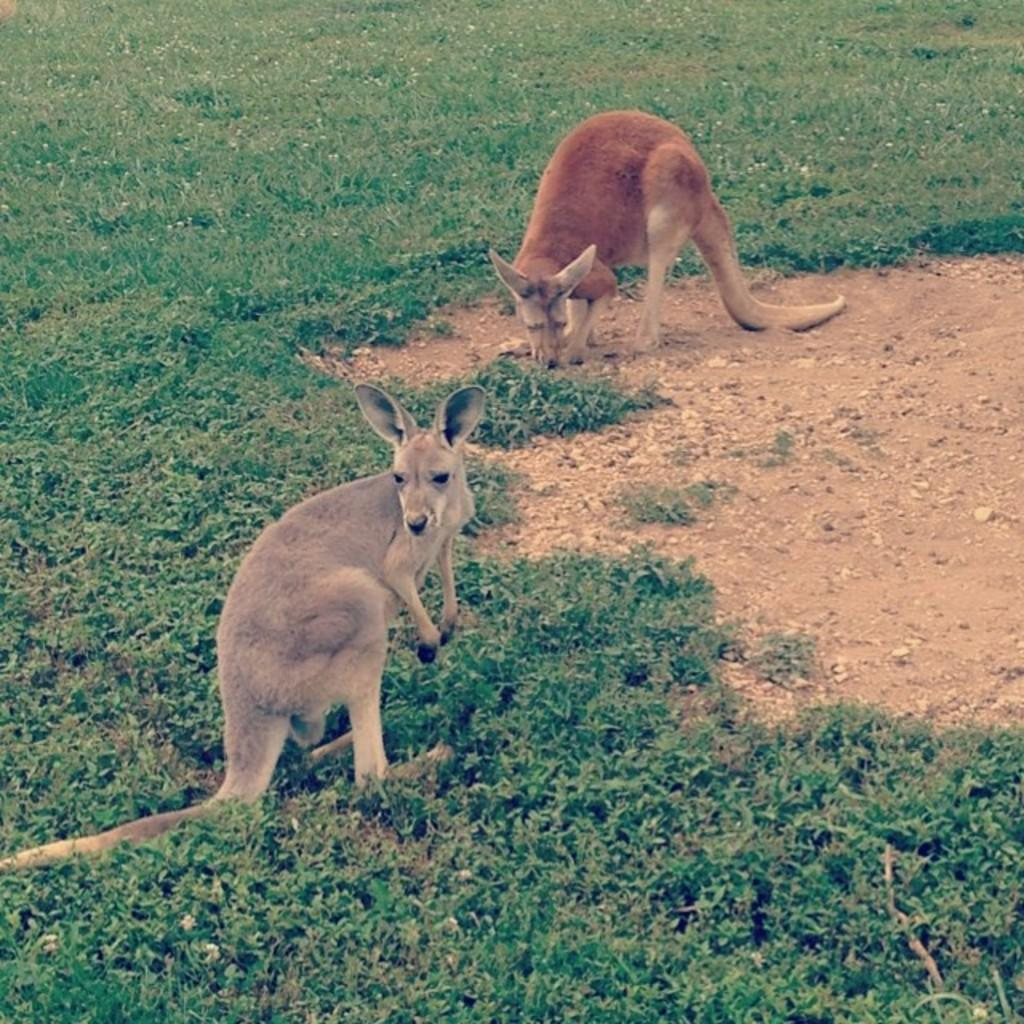How many kangaroos are in the image? There are two kangaroos in the image. What colors are the kangaroos? The kangaroos are brown, grey, and cream in color. What is the kangaroos' position in the image? The kangaroos are standing on the ground. What type of vegetation is present on the ground in the image? There is grass on the ground in the image. What color is the grass? The grass is green in color. What type of spoon or fork can be seen in the image? There is no spoon or fork present in the image; it features two kangaroos standing on green grass. 